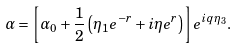<formula> <loc_0><loc_0><loc_500><loc_500>\alpha = \left [ \alpha _ { 0 } + \frac { 1 } { 2 } \left ( \eta _ { 1 } e ^ { - r } + i \eta e ^ { r } \right ) \right ] e ^ { i q \eta _ { 3 } } .</formula> 